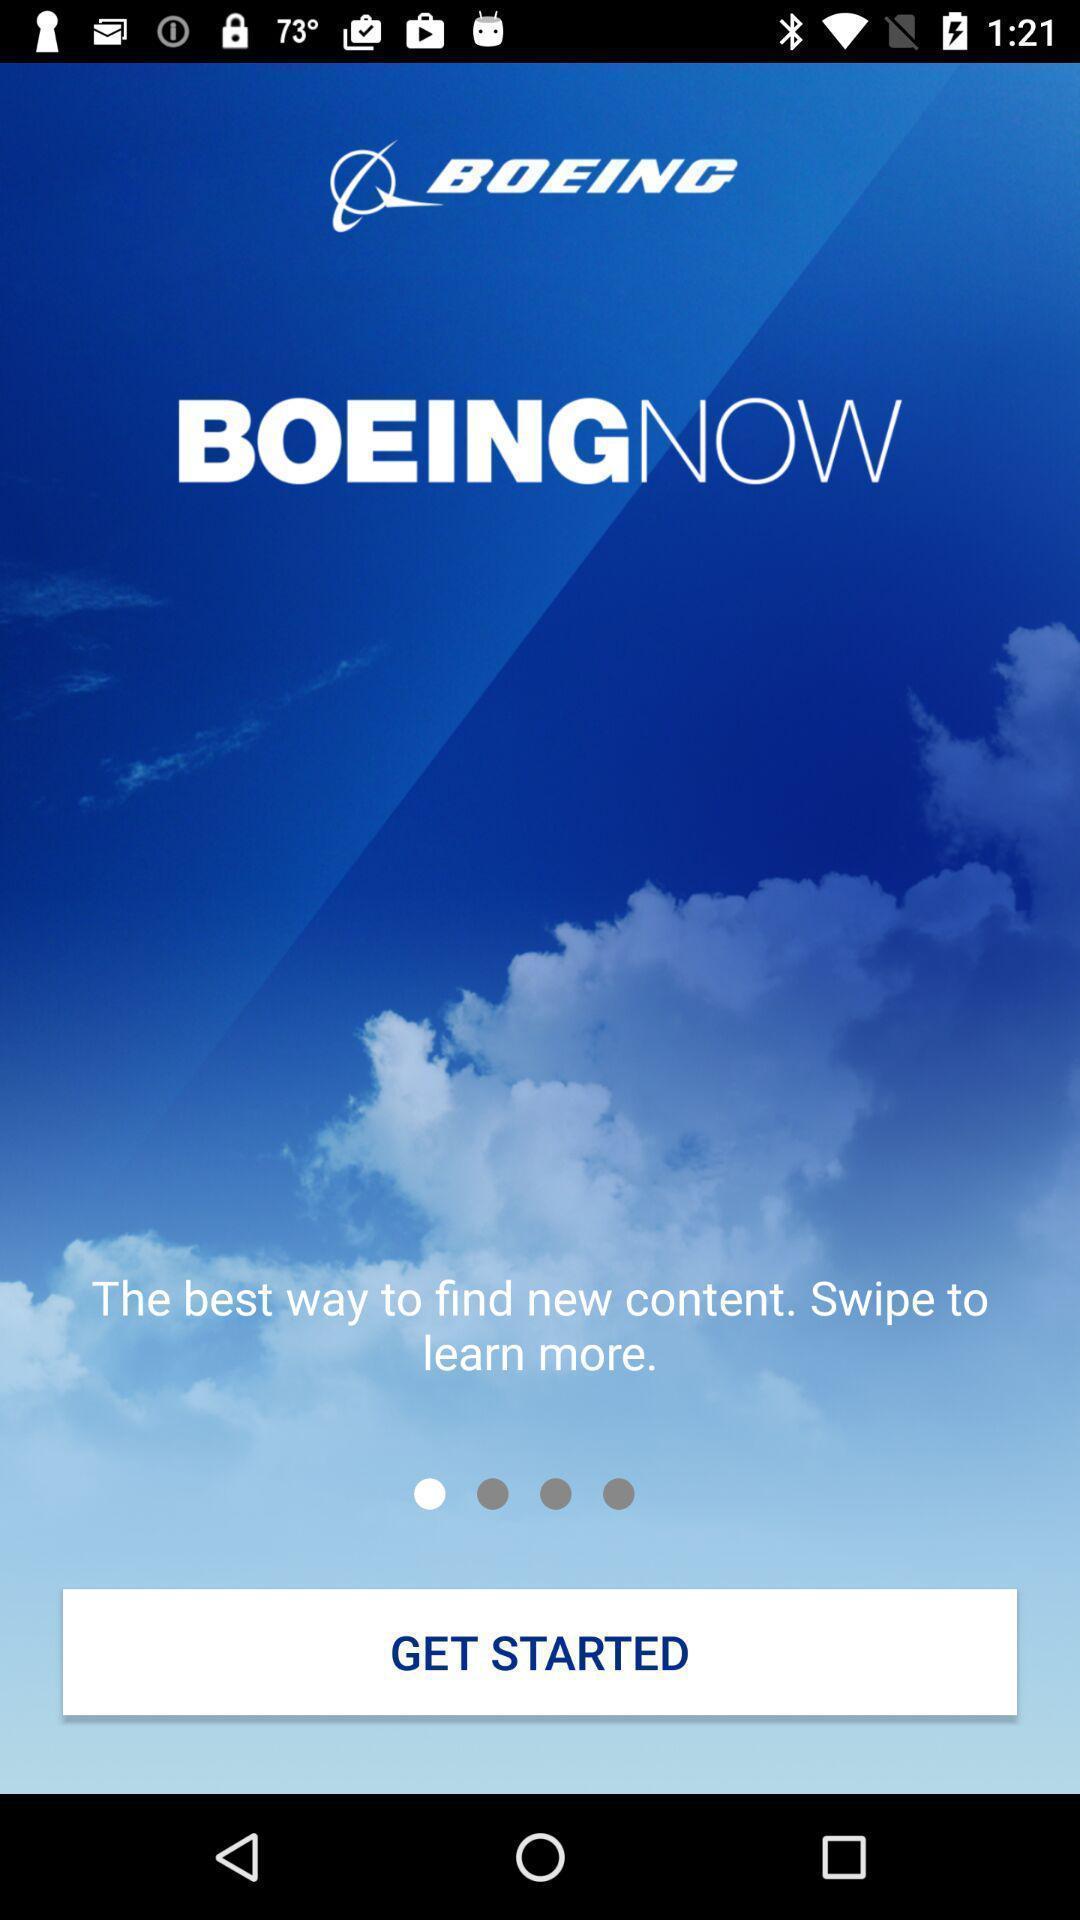Provide a description of this screenshot. Welcome page of an official app. 